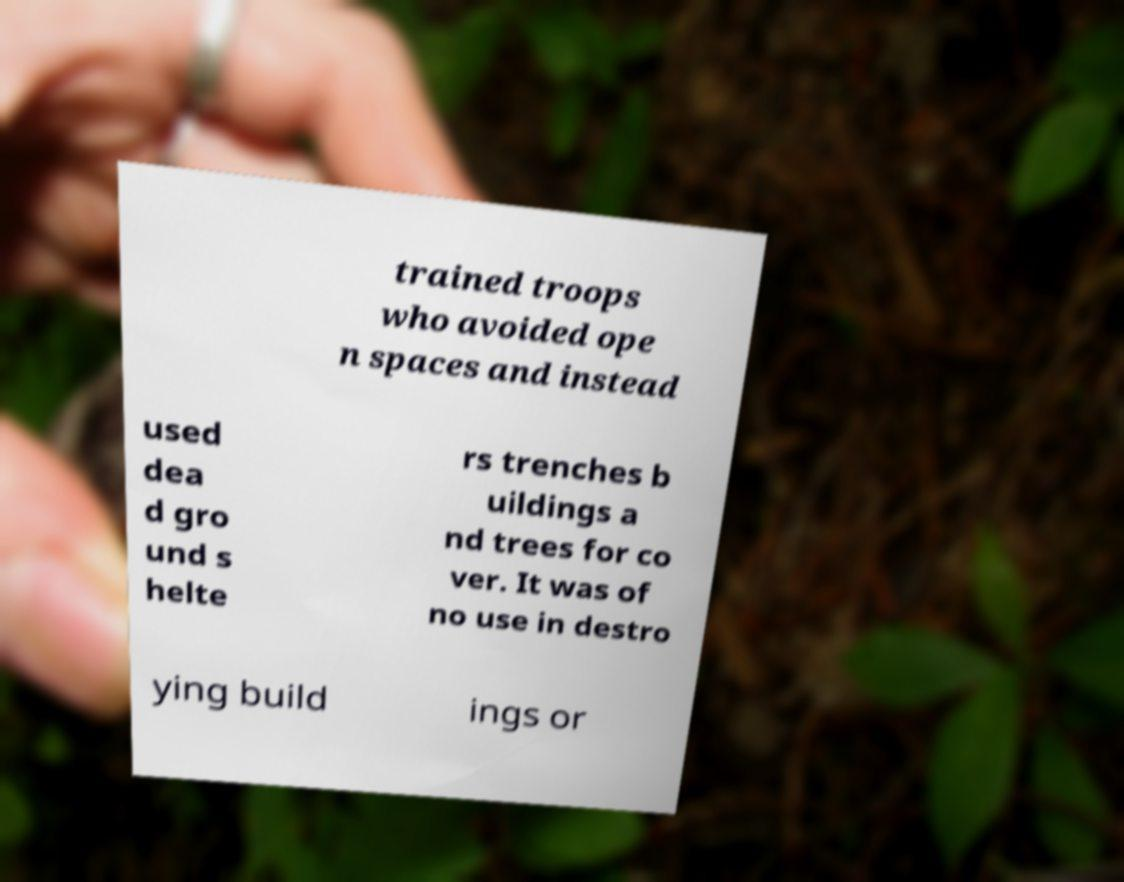There's text embedded in this image that I need extracted. Can you transcribe it verbatim? trained troops who avoided ope n spaces and instead used dea d gro und s helte rs trenches b uildings a nd trees for co ver. It was of no use in destro ying build ings or 